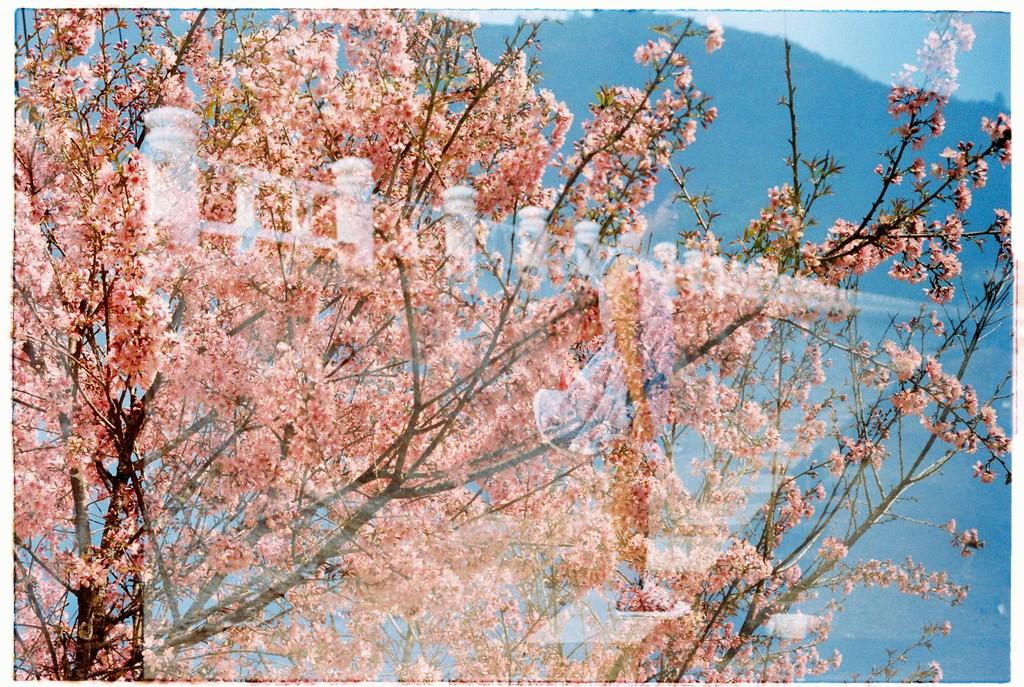What type of vegetation can be seen in the image? There are trees in the image. What other object's reflection is visible in the image? The reflection of a fence is visible in the image. How much sugar is in the trees in the image? There is no sugar present in the trees in the image. 